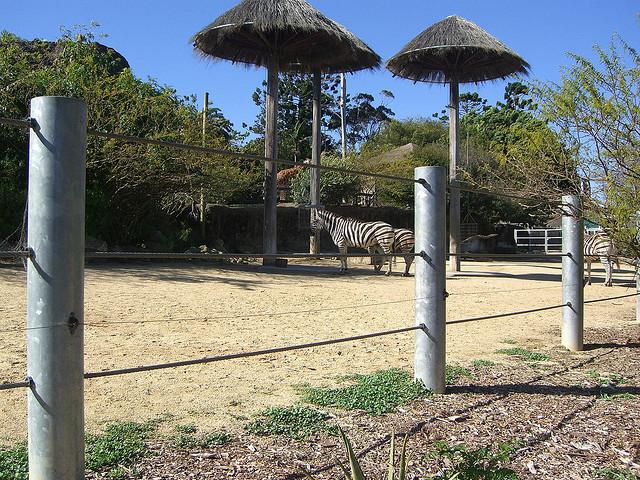What are the awnings made of?
Give a very brief answer. Straw. Are these animals enclosed?
Short answer required. Yes. What type of animals are standing in the enclosure?
Write a very short answer. Zebras. 